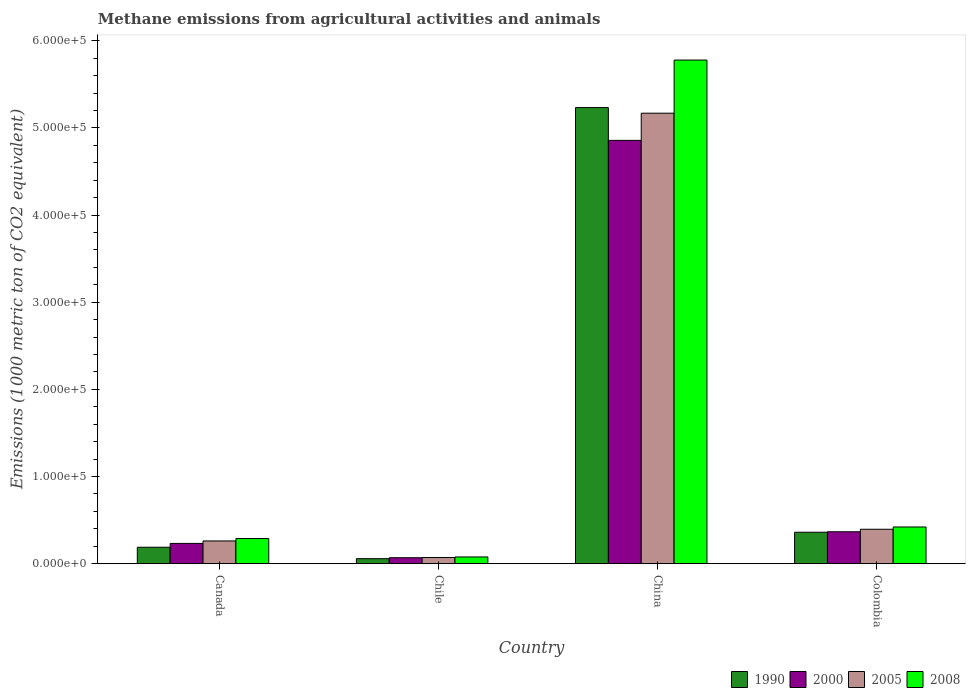How many groups of bars are there?
Offer a terse response. 4. How many bars are there on the 1st tick from the left?
Provide a short and direct response. 4. How many bars are there on the 4th tick from the right?
Ensure brevity in your answer.  4. In how many cases, is the number of bars for a given country not equal to the number of legend labels?
Ensure brevity in your answer.  0. What is the amount of methane emitted in 2000 in Colombia?
Provide a short and direct response. 3.67e+04. Across all countries, what is the maximum amount of methane emitted in 2000?
Ensure brevity in your answer.  4.86e+05. Across all countries, what is the minimum amount of methane emitted in 2008?
Offer a very short reply. 7786.1. In which country was the amount of methane emitted in 2008 minimum?
Your answer should be very brief. Chile. What is the total amount of methane emitted in 2008 in the graph?
Make the answer very short. 6.57e+05. What is the difference between the amount of methane emitted in 2000 in Chile and that in China?
Provide a short and direct response. -4.79e+05. What is the difference between the amount of methane emitted in 2000 in Canada and the amount of methane emitted in 2005 in Chile?
Ensure brevity in your answer.  1.62e+04. What is the average amount of methane emitted in 2005 per country?
Your answer should be compact. 1.47e+05. What is the difference between the amount of methane emitted of/in 2000 and amount of methane emitted of/in 1990 in China?
Make the answer very short. -3.76e+04. In how many countries, is the amount of methane emitted in 2008 greater than 500000 1000 metric ton?
Make the answer very short. 1. What is the ratio of the amount of methane emitted in 2005 in Chile to that in China?
Provide a succinct answer. 0.01. Is the amount of methane emitted in 2000 in China less than that in Colombia?
Your answer should be very brief. No. Is the difference between the amount of methane emitted in 2000 in Canada and Colombia greater than the difference between the amount of methane emitted in 1990 in Canada and Colombia?
Your answer should be compact. Yes. What is the difference between the highest and the second highest amount of methane emitted in 2008?
Provide a succinct answer. -5.49e+05. What is the difference between the highest and the lowest amount of methane emitted in 1990?
Your answer should be compact. 5.18e+05. In how many countries, is the amount of methane emitted in 2000 greater than the average amount of methane emitted in 2000 taken over all countries?
Ensure brevity in your answer.  1. Is the sum of the amount of methane emitted in 2008 in Chile and Colombia greater than the maximum amount of methane emitted in 1990 across all countries?
Provide a short and direct response. No. Is it the case that in every country, the sum of the amount of methane emitted in 2008 and amount of methane emitted in 2005 is greater than the sum of amount of methane emitted in 2000 and amount of methane emitted in 1990?
Ensure brevity in your answer.  No. How many bars are there?
Make the answer very short. 16. What is the difference between two consecutive major ticks on the Y-axis?
Provide a short and direct response. 1.00e+05. Does the graph contain any zero values?
Provide a succinct answer. No. Where does the legend appear in the graph?
Make the answer very short. Bottom right. How many legend labels are there?
Your answer should be very brief. 4. How are the legend labels stacked?
Offer a terse response. Horizontal. What is the title of the graph?
Your answer should be compact. Methane emissions from agricultural activities and animals. What is the label or title of the X-axis?
Make the answer very short. Country. What is the label or title of the Y-axis?
Your answer should be compact. Emissions (1000 metric ton of CO2 equivalent). What is the Emissions (1000 metric ton of CO2 equivalent) of 1990 in Canada?
Your answer should be very brief. 1.89e+04. What is the Emissions (1000 metric ton of CO2 equivalent) of 2000 in Canada?
Your answer should be very brief. 2.33e+04. What is the Emissions (1000 metric ton of CO2 equivalent) in 2005 in Canada?
Offer a terse response. 2.61e+04. What is the Emissions (1000 metric ton of CO2 equivalent) of 2008 in Canada?
Offer a terse response. 2.89e+04. What is the Emissions (1000 metric ton of CO2 equivalent) of 1990 in Chile?
Your response must be concise. 5805.8. What is the Emissions (1000 metric ton of CO2 equivalent) in 2000 in Chile?
Offer a very short reply. 6891.6. What is the Emissions (1000 metric ton of CO2 equivalent) in 2005 in Chile?
Give a very brief answer. 7154.5. What is the Emissions (1000 metric ton of CO2 equivalent) of 2008 in Chile?
Give a very brief answer. 7786.1. What is the Emissions (1000 metric ton of CO2 equivalent) of 1990 in China?
Make the answer very short. 5.23e+05. What is the Emissions (1000 metric ton of CO2 equivalent) in 2000 in China?
Provide a short and direct response. 4.86e+05. What is the Emissions (1000 metric ton of CO2 equivalent) of 2005 in China?
Make the answer very short. 5.17e+05. What is the Emissions (1000 metric ton of CO2 equivalent) in 2008 in China?
Offer a terse response. 5.78e+05. What is the Emissions (1000 metric ton of CO2 equivalent) in 1990 in Colombia?
Provide a short and direct response. 3.61e+04. What is the Emissions (1000 metric ton of CO2 equivalent) of 2000 in Colombia?
Your answer should be compact. 3.67e+04. What is the Emissions (1000 metric ton of CO2 equivalent) of 2005 in Colombia?
Your answer should be compact. 3.96e+04. What is the Emissions (1000 metric ton of CO2 equivalent) of 2008 in Colombia?
Offer a very short reply. 4.22e+04. Across all countries, what is the maximum Emissions (1000 metric ton of CO2 equivalent) in 1990?
Keep it short and to the point. 5.23e+05. Across all countries, what is the maximum Emissions (1000 metric ton of CO2 equivalent) of 2000?
Give a very brief answer. 4.86e+05. Across all countries, what is the maximum Emissions (1000 metric ton of CO2 equivalent) in 2005?
Your answer should be compact. 5.17e+05. Across all countries, what is the maximum Emissions (1000 metric ton of CO2 equivalent) of 2008?
Provide a succinct answer. 5.78e+05. Across all countries, what is the minimum Emissions (1000 metric ton of CO2 equivalent) of 1990?
Your answer should be compact. 5805.8. Across all countries, what is the minimum Emissions (1000 metric ton of CO2 equivalent) of 2000?
Your answer should be very brief. 6891.6. Across all countries, what is the minimum Emissions (1000 metric ton of CO2 equivalent) of 2005?
Your response must be concise. 7154.5. Across all countries, what is the minimum Emissions (1000 metric ton of CO2 equivalent) of 2008?
Your response must be concise. 7786.1. What is the total Emissions (1000 metric ton of CO2 equivalent) of 1990 in the graph?
Keep it short and to the point. 5.84e+05. What is the total Emissions (1000 metric ton of CO2 equivalent) in 2000 in the graph?
Offer a terse response. 5.53e+05. What is the total Emissions (1000 metric ton of CO2 equivalent) of 2005 in the graph?
Your answer should be compact. 5.90e+05. What is the total Emissions (1000 metric ton of CO2 equivalent) in 2008 in the graph?
Provide a succinct answer. 6.57e+05. What is the difference between the Emissions (1000 metric ton of CO2 equivalent) of 1990 in Canada and that in Chile?
Make the answer very short. 1.31e+04. What is the difference between the Emissions (1000 metric ton of CO2 equivalent) of 2000 in Canada and that in Chile?
Give a very brief answer. 1.64e+04. What is the difference between the Emissions (1000 metric ton of CO2 equivalent) of 2005 in Canada and that in Chile?
Provide a succinct answer. 1.90e+04. What is the difference between the Emissions (1000 metric ton of CO2 equivalent) of 2008 in Canada and that in Chile?
Provide a succinct answer. 2.11e+04. What is the difference between the Emissions (1000 metric ton of CO2 equivalent) of 1990 in Canada and that in China?
Ensure brevity in your answer.  -5.04e+05. What is the difference between the Emissions (1000 metric ton of CO2 equivalent) of 2000 in Canada and that in China?
Your answer should be very brief. -4.62e+05. What is the difference between the Emissions (1000 metric ton of CO2 equivalent) of 2005 in Canada and that in China?
Give a very brief answer. -4.91e+05. What is the difference between the Emissions (1000 metric ton of CO2 equivalent) of 2008 in Canada and that in China?
Provide a succinct answer. -5.49e+05. What is the difference between the Emissions (1000 metric ton of CO2 equivalent) in 1990 in Canada and that in Colombia?
Give a very brief answer. -1.72e+04. What is the difference between the Emissions (1000 metric ton of CO2 equivalent) of 2000 in Canada and that in Colombia?
Offer a terse response. -1.34e+04. What is the difference between the Emissions (1000 metric ton of CO2 equivalent) in 2005 in Canada and that in Colombia?
Your answer should be compact. -1.34e+04. What is the difference between the Emissions (1000 metric ton of CO2 equivalent) of 2008 in Canada and that in Colombia?
Offer a very short reply. -1.33e+04. What is the difference between the Emissions (1000 metric ton of CO2 equivalent) in 1990 in Chile and that in China?
Ensure brevity in your answer.  -5.18e+05. What is the difference between the Emissions (1000 metric ton of CO2 equivalent) in 2000 in Chile and that in China?
Make the answer very short. -4.79e+05. What is the difference between the Emissions (1000 metric ton of CO2 equivalent) in 2005 in Chile and that in China?
Ensure brevity in your answer.  -5.10e+05. What is the difference between the Emissions (1000 metric ton of CO2 equivalent) in 2008 in Chile and that in China?
Provide a short and direct response. -5.70e+05. What is the difference between the Emissions (1000 metric ton of CO2 equivalent) of 1990 in Chile and that in Colombia?
Your answer should be compact. -3.03e+04. What is the difference between the Emissions (1000 metric ton of CO2 equivalent) in 2000 in Chile and that in Colombia?
Offer a very short reply. -2.98e+04. What is the difference between the Emissions (1000 metric ton of CO2 equivalent) of 2005 in Chile and that in Colombia?
Make the answer very short. -3.24e+04. What is the difference between the Emissions (1000 metric ton of CO2 equivalent) of 2008 in Chile and that in Colombia?
Make the answer very short. -3.44e+04. What is the difference between the Emissions (1000 metric ton of CO2 equivalent) in 1990 in China and that in Colombia?
Your answer should be compact. 4.87e+05. What is the difference between the Emissions (1000 metric ton of CO2 equivalent) of 2000 in China and that in Colombia?
Your response must be concise. 4.49e+05. What is the difference between the Emissions (1000 metric ton of CO2 equivalent) of 2005 in China and that in Colombia?
Offer a terse response. 4.77e+05. What is the difference between the Emissions (1000 metric ton of CO2 equivalent) of 2008 in China and that in Colombia?
Offer a terse response. 5.36e+05. What is the difference between the Emissions (1000 metric ton of CO2 equivalent) of 1990 in Canada and the Emissions (1000 metric ton of CO2 equivalent) of 2000 in Chile?
Offer a very short reply. 1.20e+04. What is the difference between the Emissions (1000 metric ton of CO2 equivalent) of 1990 in Canada and the Emissions (1000 metric ton of CO2 equivalent) of 2005 in Chile?
Offer a very short reply. 1.18e+04. What is the difference between the Emissions (1000 metric ton of CO2 equivalent) of 1990 in Canada and the Emissions (1000 metric ton of CO2 equivalent) of 2008 in Chile?
Your answer should be very brief. 1.11e+04. What is the difference between the Emissions (1000 metric ton of CO2 equivalent) of 2000 in Canada and the Emissions (1000 metric ton of CO2 equivalent) of 2005 in Chile?
Make the answer very short. 1.62e+04. What is the difference between the Emissions (1000 metric ton of CO2 equivalent) in 2000 in Canada and the Emissions (1000 metric ton of CO2 equivalent) in 2008 in Chile?
Your response must be concise. 1.55e+04. What is the difference between the Emissions (1000 metric ton of CO2 equivalent) of 2005 in Canada and the Emissions (1000 metric ton of CO2 equivalent) of 2008 in Chile?
Offer a very short reply. 1.83e+04. What is the difference between the Emissions (1000 metric ton of CO2 equivalent) in 1990 in Canada and the Emissions (1000 metric ton of CO2 equivalent) in 2000 in China?
Keep it short and to the point. -4.67e+05. What is the difference between the Emissions (1000 metric ton of CO2 equivalent) in 1990 in Canada and the Emissions (1000 metric ton of CO2 equivalent) in 2005 in China?
Give a very brief answer. -4.98e+05. What is the difference between the Emissions (1000 metric ton of CO2 equivalent) in 1990 in Canada and the Emissions (1000 metric ton of CO2 equivalent) in 2008 in China?
Give a very brief answer. -5.59e+05. What is the difference between the Emissions (1000 metric ton of CO2 equivalent) of 2000 in Canada and the Emissions (1000 metric ton of CO2 equivalent) of 2005 in China?
Your answer should be compact. -4.94e+05. What is the difference between the Emissions (1000 metric ton of CO2 equivalent) of 2000 in Canada and the Emissions (1000 metric ton of CO2 equivalent) of 2008 in China?
Your answer should be compact. -5.55e+05. What is the difference between the Emissions (1000 metric ton of CO2 equivalent) of 2005 in Canada and the Emissions (1000 metric ton of CO2 equivalent) of 2008 in China?
Offer a very short reply. -5.52e+05. What is the difference between the Emissions (1000 metric ton of CO2 equivalent) of 1990 in Canada and the Emissions (1000 metric ton of CO2 equivalent) of 2000 in Colombia?
Your response must be concise. -1.78e+04. What is the difference between the Emissions (1000 metric ton of CO2 equivalent) of 1990 in Canada and the Emissions (1000 metric ton of CO2 equivalent) of 2005 in Colombia?
Offer a very short reply. -2.06e+04. What is the difference between the Emissions (1000 metric ton of CO2 equivalent) of 1990 in Canada and the Emissions (1000 metric ton of CO2 equivalent) of 2008 in Colombia?
Make the answer very short. -2.32e+04. What is the difference between the Emissions (1000 metric ton of CO2 equivalent) in 2000 in Canada and the Emissions (1000 metric ton of CO2 equivalent) in 2005 in Colombia?
Ensure brevity in your answer.  -1.62e+04. What is the difference between the Emissions (1000 metric ton of CO2 equivalent) in 2000 in Canada and the Emissions (1000 metric ton of CO2 equivalent) in 2008 in Colombia?
Provide a succinct answer. -1.88e+04. What is the difference between the Emissions (1000 metric ton of CO2 equivalent) in 2005 in Canada and the Emissions (1000 metric ton of CO2 equivalent) in 2008 in Colombia?
Provide a succinct answer. -1.60e+04. What is the difference between the Emissions (1000 metric ton of CO2 equivalent) of 1990 in Chile and the Emissions (1000 metric ton of CO2 equivalent) of 2000 in China?
Provide a succinct answer. -4.80e+05. What is the difference between the Emissions (1000 metric ton of CO2 equivalent) of 1990 in Chile and the Emissions (1000 metric ton of CO2 equivalent) of 2005 in China?
Offer a terse response. -5.11e+05. What is the difference between the Emissions (1000 metric ton of CO2 equivalent) in 1990 in Chile and the Emissions (1000 metric ton of CO2 equivalent) in 2008 in China?
Offer a very short reply. -5.72e+05. What is the difference between the Emissions (1000 metric ton of CO2 equivalent) of 2000 in Chile and the Emissions (1000 metric ton of CO2 equivalent) of 2005 in China?
Your response must be concise. -5.10e+05. What is the difference between the Emissions (1000 metric ton of CO2 equivalent) in 2000 in Chile and the Emissions (1000 metric ton of CO2 equivalent) in 2008 in China?
Your response must be concise. -5.71e+05. What is the difference between the Emissions (1000 metric ton of CO2 equivalent) in 2005 in Chile and the Emissions (1000 metric ton of CO2 equivalent) in 2008 in China?
Ensure brevity in your answer.  -5.71e+05. What is the difference between the Emissions (1000 metric ton of CO2 equivalent) in 1990 in Chile and the Emissions (1000 metric ton of CO2 equivalent) in 2000 in Colombia?
Keep it short and to the point. -3.09e+04. What is the difference between the Emissions (1000 metric ton of CO2 equivalent) of 1990 in Chile and the Emissions (1000 metric ton of CO2 equivalent) of 2005 in Colombia?
Your answer should be very brief. -3.37e+04. What is the difference between the Emissions (1000 metric ton of CO2 equivalent) in 1990 in Chile and the Emissions (1000 metric ton of CO2 equivalent) in 2008 in Colombia?
Keep it short and to the point. -3.64e+04. What is the difference between the Emissions (1000 metric ton of CO2 equivalent) of 2000 in Chile and the Emissions (1000 metric ton of CO2 equivalent) of 2005 in Colombia?
Give a very brief answer. -3.27e+04. What is the difference between the Emissions (1000 metric ton of CO2 equivalent) of 2000 in Chile and the Emissions (1000 metric ton of CO2 equivalent) of 2008 in Colombia?
Provide a short and direct response. -3.53e+04. What is the difference between the Emissions (1000 metric ton of CO2 equivalent) of 2005 in Chile and the Emissions (1000 metric ton of CO2 equivalent) of 2008 in Colombia?
Provide a short and direct response. -3.50e+04. What is the difference between the Emissions (1000 metric ton of CO2 equivalent) of 1990 in China and the Emissions (1000 metric ton of CO2 equivalent) of 2000 in Colombia?
Keep it short and to the point. 4.87e+05. What is the difference between the Emissions (1000 metric ton of CO2 equivalent) in 1990 in China and the Emissions (1000 metric ton of CO2 equivalent) in 2005 in Colombia?
Your answer should be very brief. 4.84e+05. What is the difference between the Emissions (1000 metric ton of CO2 equivalent) in 1990 in China and the Emissions (1000 metric ton of CO2 equivalent) in 2008 in Colombia?
Your answer should be compact. 4.81e+05. What is the difference between the Emissions (1000 metric ton of CO2 equivalent) in 2000 in China and the Emissions (1000 metric ton of CO2 equivalent) in 2005 in Colombia?
Ensure brevity in your answer.  4.46e+05. What is the difference between the Emissions (1000 metric ton of CO2 equivalent) in 2000 in China and the Emissions (1000 metric ton of CO2 equivalent) in 2008 in Colombia?
Your answer should be compact. 4.44e+05. What is the difference between the Emissions (1000 metric ton of CO2 equivalent) of 2005 in China and the Emissions (1000 metric ton of CO2 equivalent) of 2008 in Colombia?
Keep it short and to the point. 4.75e+05. What is the average Emissions (1000 metric ton of CO2 equivalent) in 1990 per country?
Your answer should be very brief. 1.46e+05. What is the average Emissions (1000 metric ton of CO2 equivalent) of 2000 per country?
Your response must be concise. 1.38e+05. What is the average Emissions (1000 metric ton of CO2 equivalent) in 2005 per country?
Offer a very short reply. 1.47e+05. What is the average Emissions (1000 metric ton of CO2 equivalent) of 2008 per country?
Your answer should be compact. 1.64e+05. What is the difference between the Emissions (1000 metric ton of CO2 equivalent) of 1990 and Emissions (1000 metric ton of CO2 equivalent) of 2000 in Canada?
Give a very brief answer. -4391.7. What is the difference between the Emissions (1000 metric ton of CO2 equivalent) in 1990 and Emissions (1000 metric ton of CO2 equivalent) in 2005 in Canada?
Offer a terse response. -7210.8. What is the difference between the Emissions (1000 metric ton of CO2 equivalent) of 1990 and Emissions (1000 metric ton of CO2 equivalent) of 2008 in Canada?
Give a very brief answer. -9973.1. What is the difference between the Emissions (1000 metric ton of CO2 equivalent) in 2000 and Emissions (1000 metric ton of CO2 equivalent) in 2005 in Canada?
Provide a succinct answer. -2819.1. What is the difference between the Emissions (1000 metric ton of CO2 equivalent) of 2000 and Emissions (1000 metric ton of CO2 equivalent) of 2008 in Canada?
Ensure brevity in your answer.  -5581.4. What is the difference between the Emissions (1000 metric ton of CO2 equivalent) in 2005 and Emissions (1000 metric ton of CO2 equivalent) in 2008 in Canada?
Keep it short and to the point. -2762.3. What is the difference between the Emissions (1000 metric ton of CO2 equivalent) of 1990 and Emissions (1000 metric ton of CO2 equivalent) of 2000 in Chile?
Give a very brief answer. -1085.8. What is the difference between the Emissions (1000 metric ton of CO2 equivalent) in 1990 and Emissions (1000 metric ton of CO2 equivalent) in 2005 in Chile?
Offer a very short reply. -1348.7. What is the difference between the Emissions (1000 metric ton of CO2 equivalent) of 1990 and Emissions (1000 metric ton of CO2 equivalent) of 2008 in Chile?
Your response must be concise. -1980.3. What is the difference between the Emissions (1000 metric ton of CO2 equivalent) of 2000 and Emissions (1000 metric ton of CO2 equivalent) of 2005 in Chile?
Provide a succinct answer. -262.9. What is the difference between the Emissions (1000 metric ton of CO2 equivalent) of 2000 and Emissions (1000 metric ton of CO2 equivalent) of 2008 in Chile?
Offer a very short reply. -894.5. What is the difference between the Emissions (1000 metric ton of CO2 equivalent) of 2005 and Emissions (1000 metric ton of CO2 equivalent) of 2008 in Chile?
Offer a very short reply. -631.6. What is the difference between the Emissions (1000 metric ton of CO2 equivalent) of 1990 and Emissions (1000 metric ton of CO2 equivalent) of 2000 in China?
Offer a terse response. 3.76e+04. What is the difference between the Emissions (1000 metric ton of CO2 equivalent) of 1990 and Emissions (1000 metric ton of CO2 equivalent) of 2005 in China?
Provide a short and direct response. 6449.7. What is the difference between the Emissions (1000 metric ton of CO2 equivalent) of 1990 and Emissions (1000 metric ton of CO2 equivalent) of 2008 in China?
Offer a terse response. -5.45e+04. What is the difference between the Emissions (1000 metric ton of CO2 equivalent) in 2000 and Emissions (1000 metric ton of CO2 equivalent) in 2005 in China?
Your response must be concise. -3.12e+04. What is the difference between the Emissions (1000 metric ton of CO2 equivalent) of 2000 and Emissions (1000 metric ton of CO2 equivalent) of 2008 in China?
Your answer should be compact. -9.21e+04. What is the difference between the Emissions (1000 metric ton of CO2 equivalent) in 2005 and Emissions (1000 metric ton of CO2 equivalent) in 2008 in China?
Provide a succinct answer. -6.10e+04. What is the difference between the Emissions (1000 metric ton of CO2 equivalent) in 1990 and Emissions (1000 metric ton of CO2 equivalent) in 2000 in Colombia?
Your answer should be very brief. -546.7. What is the difference between the Emissions (1000 metric ton of CO2 equivalent) in 1990 and Emissions (1000 metric ton of CO2 equivalent) in 2005 in Colombia?
Your answer should be very brief. -3428.3. What is the difference between the Emissions (1000 metric ton of CO2 equivalent) of 1990 and Emissions (1000 metric ton of CO2 equivalent) of 2008 in Colombia?
Your response must be concise. -6031.9. What is the difference between the Emissions (1000 metric ton of CO2 equivalent) in 2000 and Emissions (1000 metric ton of CO2 equivalent) in 2005 in Colombia?
Your answer should be compact. -2881.6. What is the difference between the Emissions (1000 metric ton of CO2 equivalent) in 2000 and Emissions (1000 metric ton of CO2 equivalent) in 2008 in Colombia?
Your answer should be very brief. -5485.2. What is the difference between the Emissions (1000 metric ton of CO2 equivalent) of 2005 and Emissions (1000 metric ton of CO2 equivalent) of 2008 in Colombia?
Offer a terse response. -2603.6. What is the ratio of the Emissions (1000 metric ton of CO2 equivalent) in 1990 in Canada to that in Chile?
Offer a very short reply. 3.26. What is the ratio of the Emissions (1000 metric ton of CO2 equivalent) in 2000 in Canada to that in Chile?
Your response must be concise. 3.38. What is the ratio of the Emissions (1000 metric ton of CO2 equivalent) of 2005 in Canada to that in Chile?
Make the answer very short. 3.65. What is the ratio of the Emissions (1000 metric ton of CO2 equivalent) of 2008 in Canada to that in Chile?
Ensure brevity in your answer.  3.71. What is the ratio of the Emissions (1000 metric ton of CO2 equivalent) in 1990 in Canada to that in China?
Your response must be concise. 0.04. What is the ratio of the Emissions (1000 metric ton of CO2 equivalent) of 2000 in Canada to that in China?
Your answer should be very brief. 0.05. What is the ratio of the Emissions (1000 metric ton of CO2 equivalent) of 2005 in Canada to that in China?
Your response must be concise. 0.05. What is the ratio of the Emissions (1000 metric ton of CO2 equivalent) in 2008 in Canada to that in China?
Make the answer very short. 0.05. What is the ratio of the Emissions (1000 metric ton of CO2 equivalent) of 1990 in Canada to that in Colombia?
Your response must be concise. 0.52. What is the ratio of the Emissions (1000 metric ton of CO2 equivalent) of 2000 in Canada to that in Colombia?
Provide a short and direct response. 0.64. What is the ratio of the Emissions (1000 metric ton of CO2 equivalent) of 2005 in Canada to that in Colombia?
Your response must be concise. 0.66. What is the ratio of the Emissions (1000 metric ton of CO2 equivalent) in 2008 in Canada to that in Colombia?
Give a very brief answer. 0.69. What is the ratio of the Emissions (1000 metric ton of CO2 equivalent) in 1990 in Chile to that in China?
Your answer should be compact. 0.01. What is the ratio of the Emissions (1000 metric ton of CO2 equivalent) in 2000 in Chile to that in China?
Your response must be concise. 0.01. What is the ratio of the Emissions (1000 metric ton of CO2 equivalent) in 2005 in Chile to that in China?
Provide a succinct answer. 0.01. What is the ratio of the Emissions (1000 metric ton of CO2 equivalent) of 2008 in Chile to that in China?
Give a very brief answer. 0.01. What is the ratio of the Emissions (1000 metric ton of CO2 equivalent) in 1990 in Chile to that in Colombia?
Make the answer very short. 0.16. What is the ratio of the Emissions (1000 metric ton of CO2 equivalent) in 2000 in Chile to that in Colombia?
Make the answer very short. 0.19. What is the ratio of the Emissions (1000 metric ton of CO2 equivalent) of 2005 in Chile to that in Colombia?
Offer a very short reply. 0.18. What is the ratio of the Emissions (1000 metric ton of CO2 equivalent) of 2008 in Chile to that in Colombia?
Make the answer very short. 0.18. What is the ratio of the Emissions (1000 metric ton of CO2 equivalent) of 1990 in China to that in Colombia?
Your answer should be very brief. 14.49. What is the ratio of the Emissions (1000 metric ton of CO2 equivalent) of 2000 in China to that in Colombia?
Ensure brevity in your answer.  13.24. What is the ratio of the Emissions (1000 metric ton of CO2 equivalent) in 2005 in China to that in Colombia?
Your answer should be compact. 13.07. What is the ratio of the Emissions (1000 metric ton of CO2 equivalent) in 2008 in China to that in Colombia?
Ensure brevity in your answer.  13.71. What is the difference between the highest and the second highest Emissions (1000 metric ton of CO2 equivalent) of 1990?
Ensure brevity in your answer.  4.87e+05. What is the difference between the highest and the second highest Emissions (1000 metric ton of CO2 equivalent) of 2000?
Provide a succinct answer. 4.49e+05. What is the difference between the highest and the second highest Emissions (1000 metric ton of CO2 equivalent) of 2005?
Offer a very short reply. 4.77e+05. What is the difference between the highest and the second highest Emissions (1000 metric ton of CO2 equivalent) in 2008?
Provide a short and direct response. 5.36e+05. What is the difference between the highest and the lowest Emissions (1000 metric ton of CO2 equivalent) of 1990?
Make the answer very short. 5.18e+05. What is the difference between the highest and the lowest Emissions (1000 metric ton of CO2 equivalent) of 2000?
Make the answer very short. 4.79e+05. What is the difference between the highest and the lowest Emissions (1000 metric ton of CO2 equivalent) in 2005?
Your answer should be compact. 5.10e+05. What is the difference between the highest and the lowest Emissions (1000 metric ton of CO2 equivalent) of 2008?
Keep it short and to the point. 5.70e+05. 